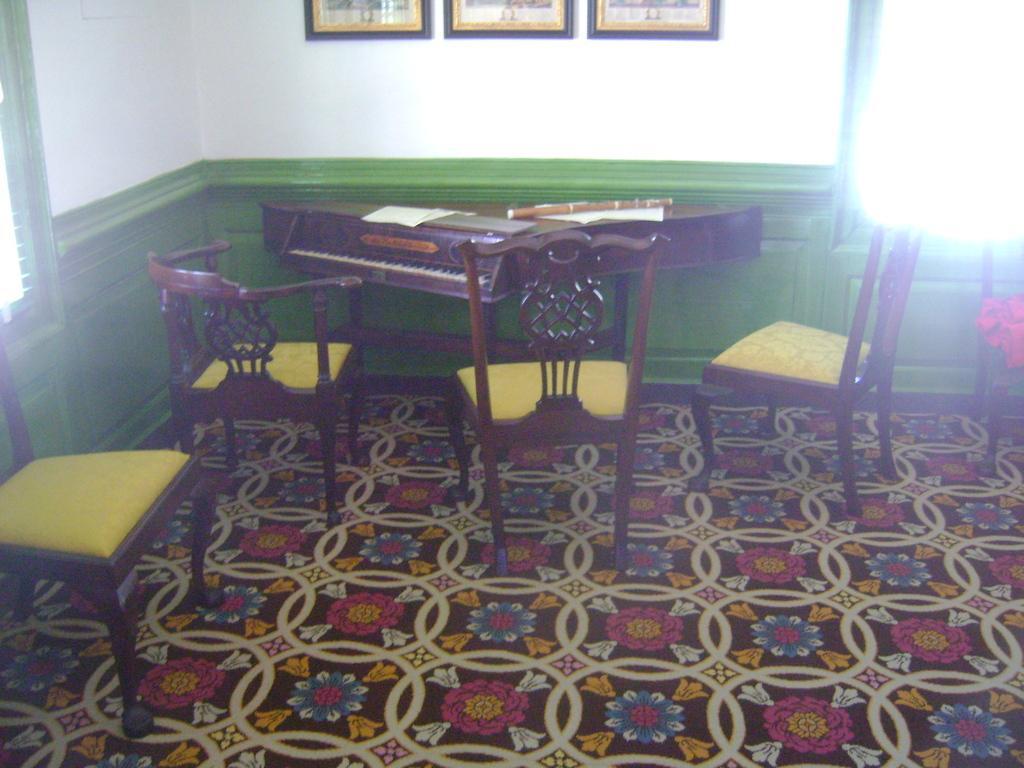How would you summarize this image in a sentence or two? There is a table on the middle of the room. There is a paper ,wooden stick on a table. There is a chair and stool on the right side of the room. There is a another chair on the left side of the room. We can see in background wall,photo frames. 